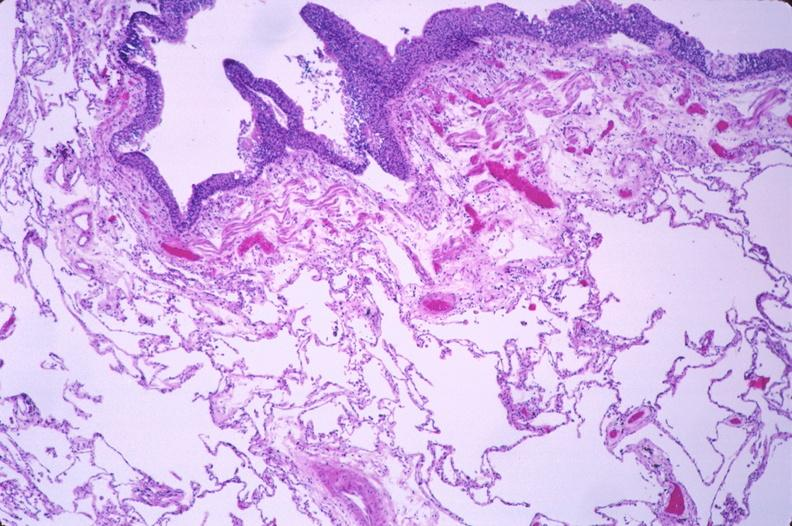what is present?
Answer the question using a single word or phrase. Respiratory 